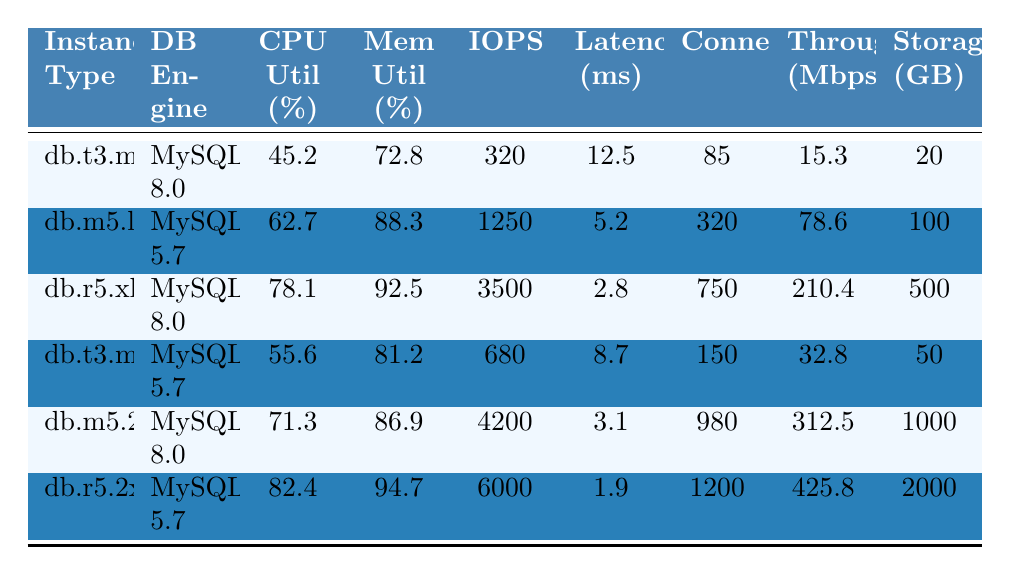What is the CPU utilization for the db.r5.2xlarge instance? The CPU utilization for the db.r5.2xlarge instance is listed directly in the table as 82.4%.
Answer: 82.4% Which instance type has the highest memory utilization? By inspecting the table, the db.r5.2xlarge instance has the highest memory utilization at 94.7%.
Answer: db.r5.2xlarge What is the difference in IOPS between db.m5.2xlarge and db.t3.medium? The IOPS for db.m5.2xlarge is 4200 and for db.t3.medium is 680. The difference is 4200 - 680 = 3520.
Answer: 3520 How many connections does the db.m5.large instance support? The table indicates that the db.m5.large instance supports 320 connections, as specified in the 'Connections' column.
Answer: 320 What is the average latency of all instances listed? To find the average latency, sum the latency values: (12.5 + 5.2 + 2.8 + 8.7 + 3.1 + 1.9) = 34.2 ms, then divide by 6 instances: 34.2 / 6 = 5.7 ms.
Answer: 5.7 Is the throughput for db.r5.xlarge greater than db.t3.medium? The throughput for db.r5.xlarge is 210.4 Mbps, while for db.t3.medium it is 32.8 Mbps. 210.4 > 32.8, so the statement is true.
Answer: Yes What is the total storage capacity of all instances combined? The total storage is calculated by summing the storage values: 20 + 100 + 500 + 50 + 1000 + 2000 = 2670 GB.
Answer: 2670 Which database engine has the highest CPU utilization in the table? By examining the table, the db.r5.2xlarge with MySQL 5.7 has the highest CPU utilization at 82.4%, which is greater than others.
Answer: MySQL 5.7 What is the relationship between instance type and throughput, specifically for MySQL 8.0? Among instances with MySQL 8.0, db.m5.2xlarge has the highest throughput at 312.5 Mbps while db.t3.micro has only 15.3 Mbps, indicating higher performance with higher instance types.
Answer: Higher instance types yield higher throughput 